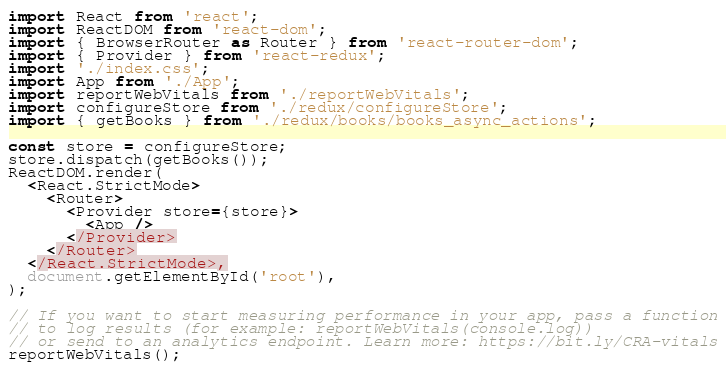<code> <loc_0><loc_0><loc_500><loc_500><_JavaScript_>import React from 'react';
import ReactDOM from 'react-dom';
import { BrowserRouter as Router } from 'react-router-dom';
import { Provider } from 'react-redux';
import './index.css';
import App from './App';
import reportWebVitals from './reportWebVitals';
import configureStore from './redux/configureStore';
import { getBooks } from './redux/books/books_async_actions';

const store = configureStore;
store.dispatch(getBooks());
ReactDOM.render(
  <React.StrictMode>
    <Router>
      <Provider store={store}>
        <App />
      </Provider>
    </Router>
  </React.StrictMode>,
  document.getElementById('root'),
);

// If you want to start measuring performance in your app, pass a function
// to log results (for example: reportWebVitals(console.log))
// or send to an analytics endpoint. Learn more: https://bit.ly/CRA-vitals
reportWebVitals();
</code> 